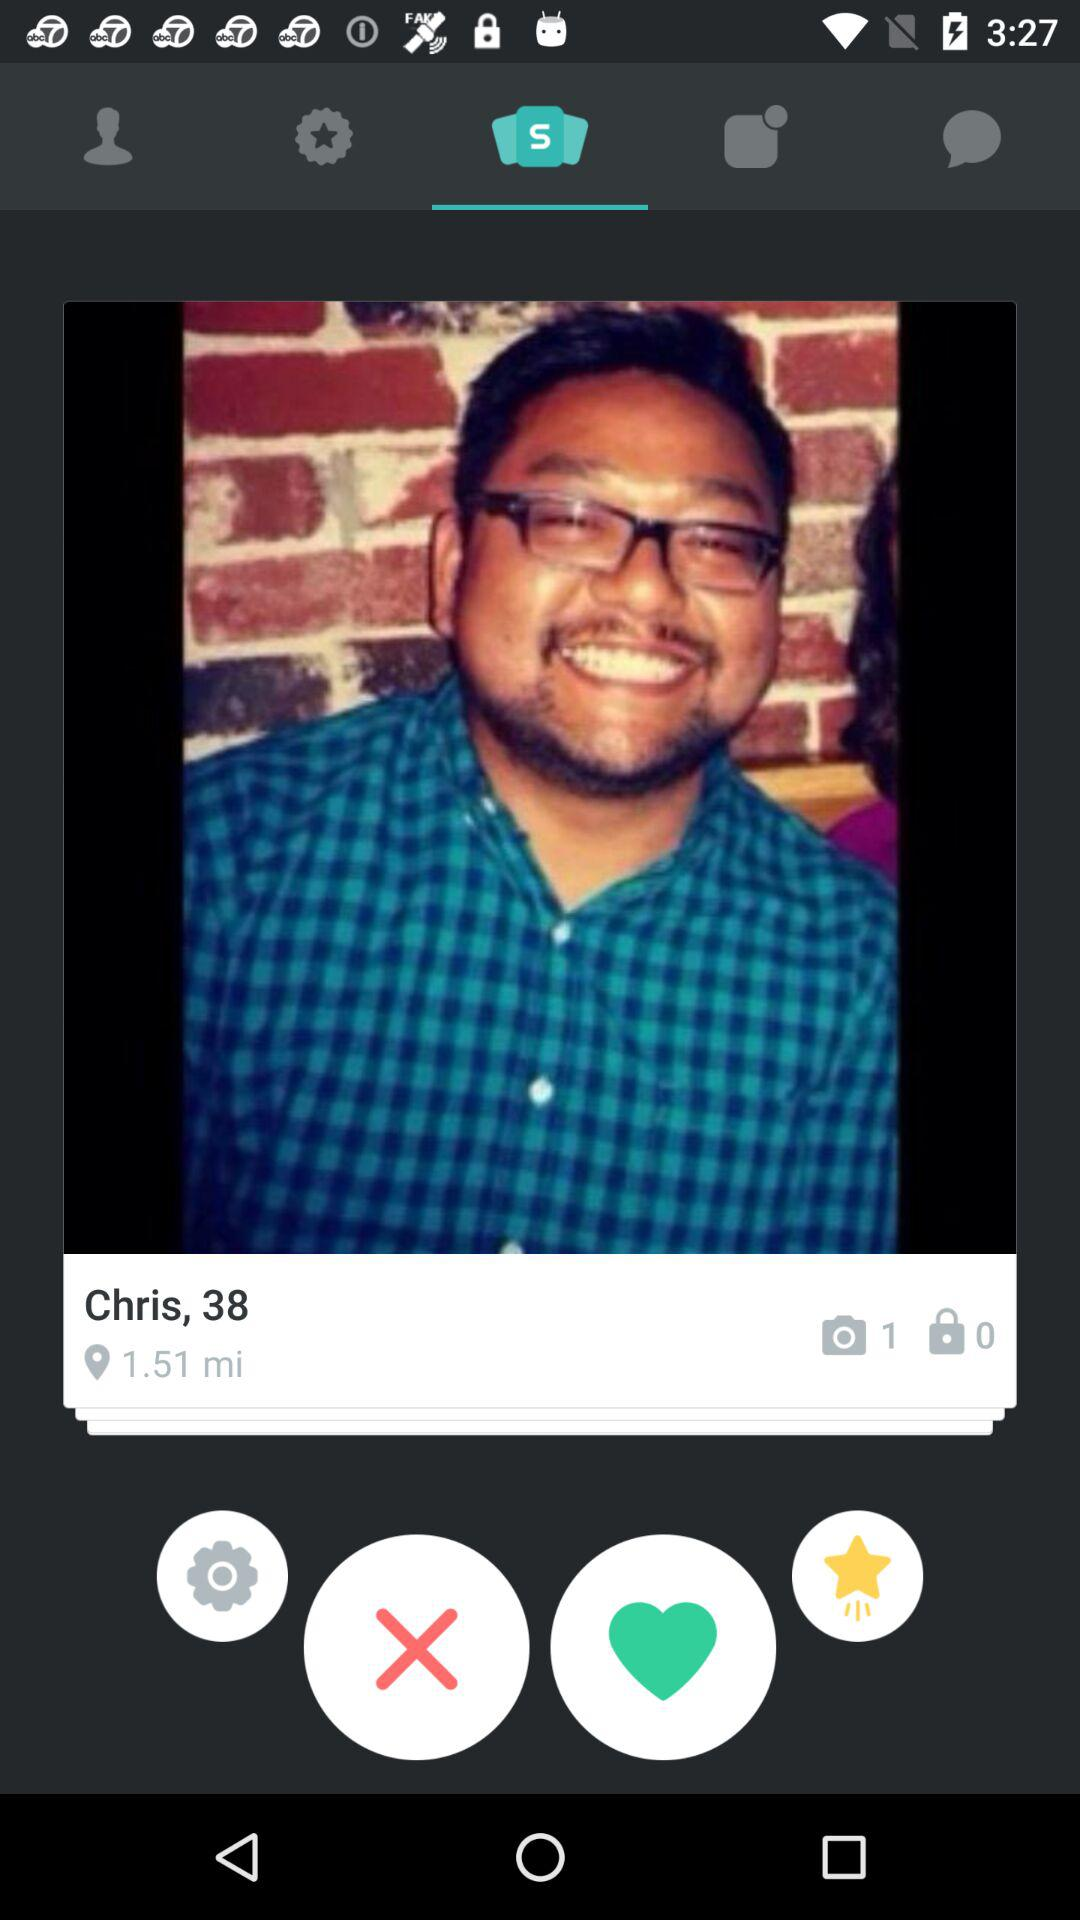How many more photos have been taken than locked?
Answer the question using a single word or phrase. 1 